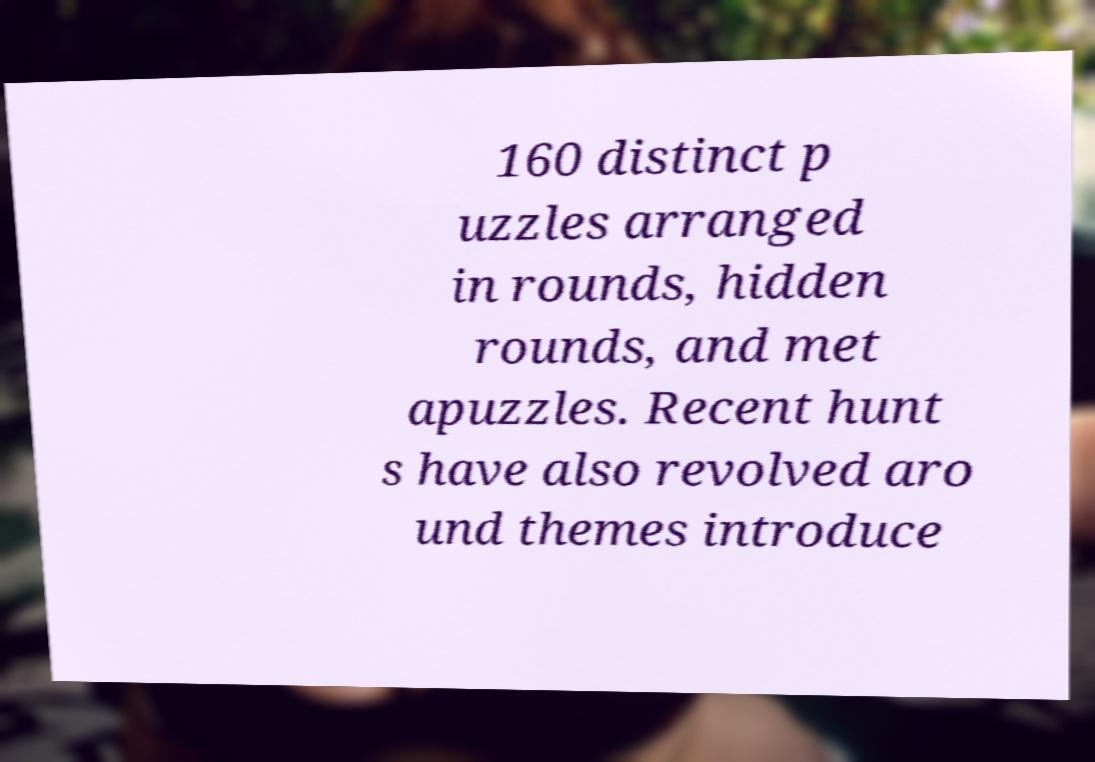I need the written content from this picture converted into text. Can you do that? 160 distinct p uzzles arranged in rounds, hidden rounds, and met apuzzles. Recent hunt s have also revolved aro und themes introduce 